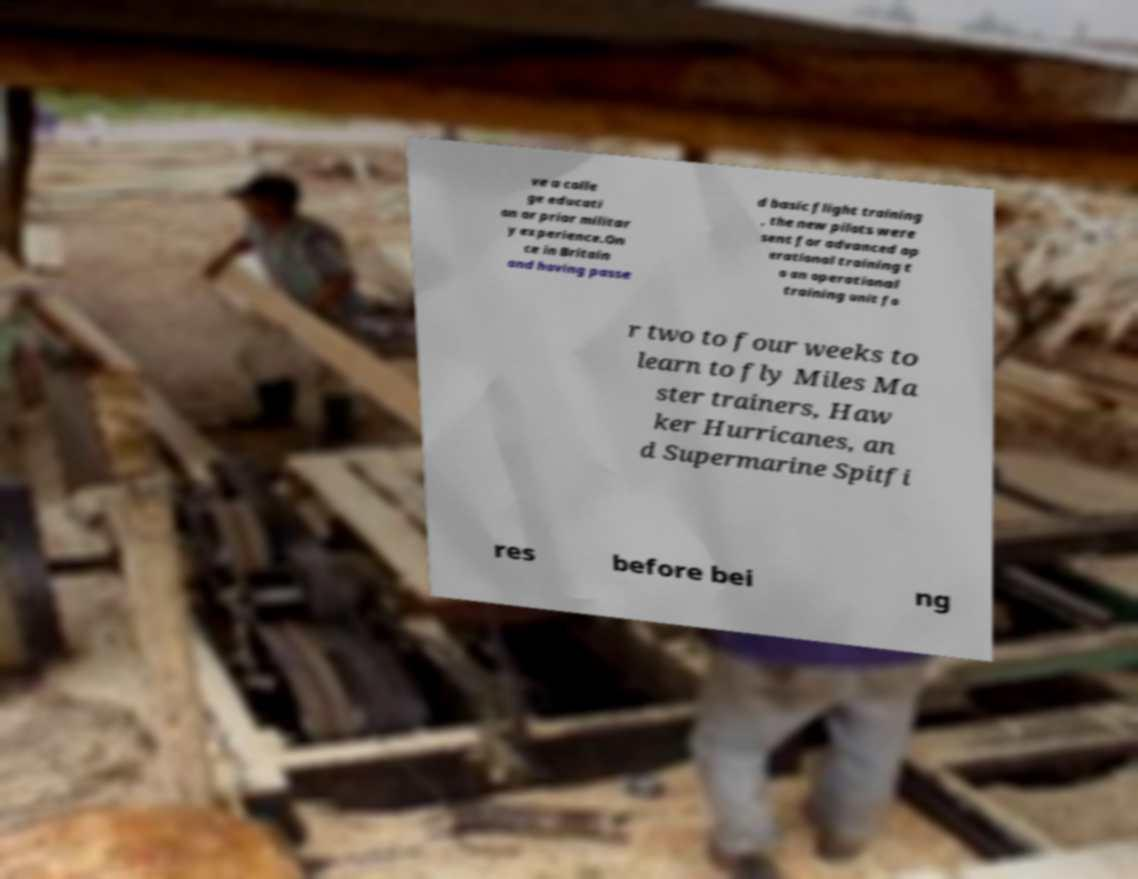Please read and relay the text visible in this image. What does it say? ve a colle ge educati on or prior militar y experience.On ce in Britain and having passe d basic flight training , the new pilots were sent for advanced op erational training t o an operational training unit fo r two to four weeks to learn to fly Miles Ma ster trainers, Haw ker Hurricanes, an d Supermarine Spitfi res before bei ng 